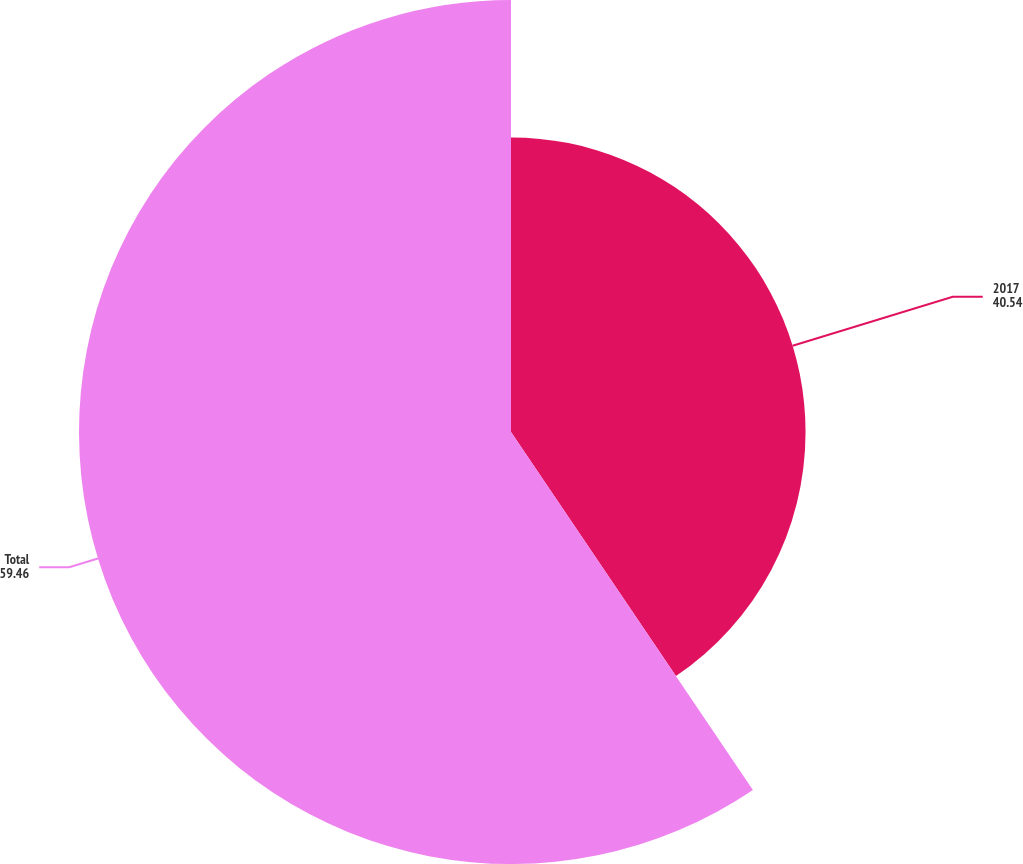<chart> <loc_0><loc_0><loc_500><loc_500><pie_chart><fcel>2017<fcel>Total<nl><fcel>40.54%<fcel>59.46%<nl></chart> 